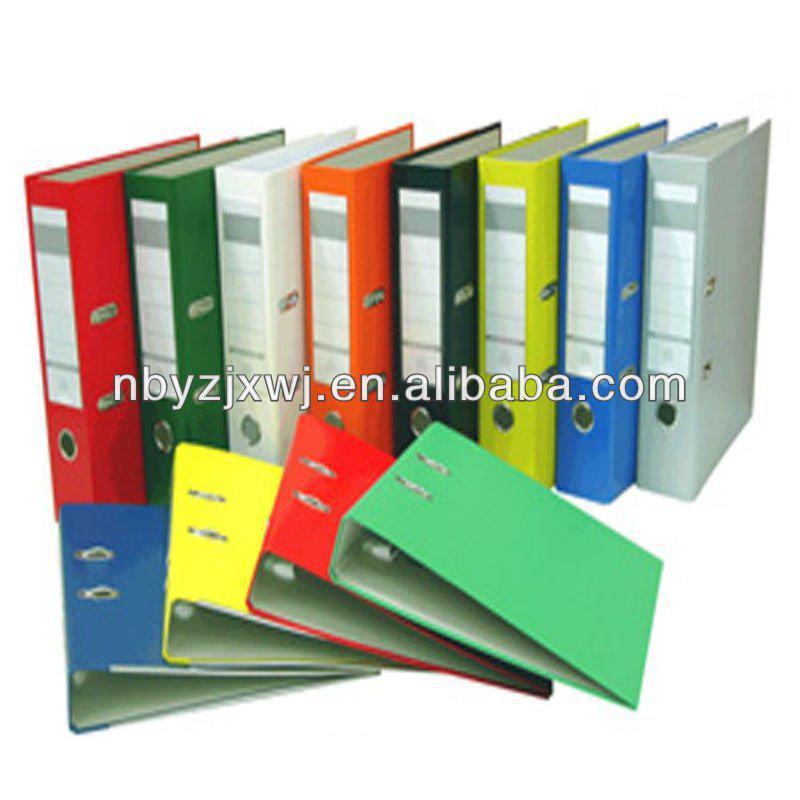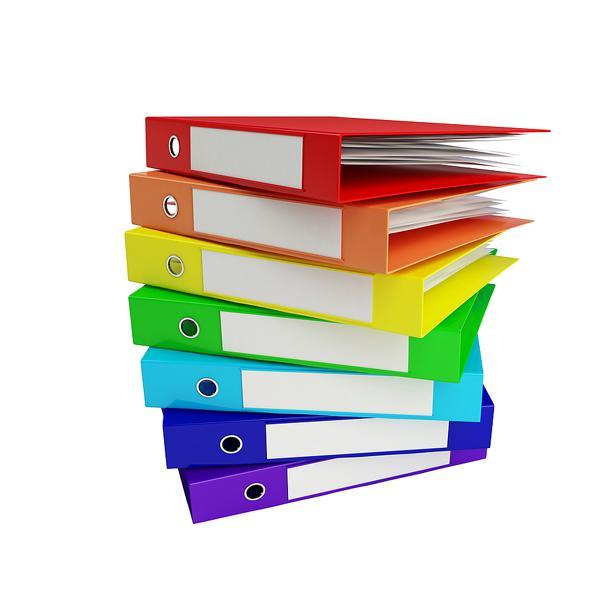The first image is the image on the left, the second image is the image on the right. Analyze the images presented: Is the assertion "In one image, a row of notebooks in various colors stands on end, while a second image shows a single notebook open to show three rings and its contents." valid? Answer yes or no. No. The first image is the image on the left, the second image is the image on the right. Assess this claim about the two images: "An image shows one opened binder filled with supplies, including a pen.". Correct or not? Answer yes or no. No. 